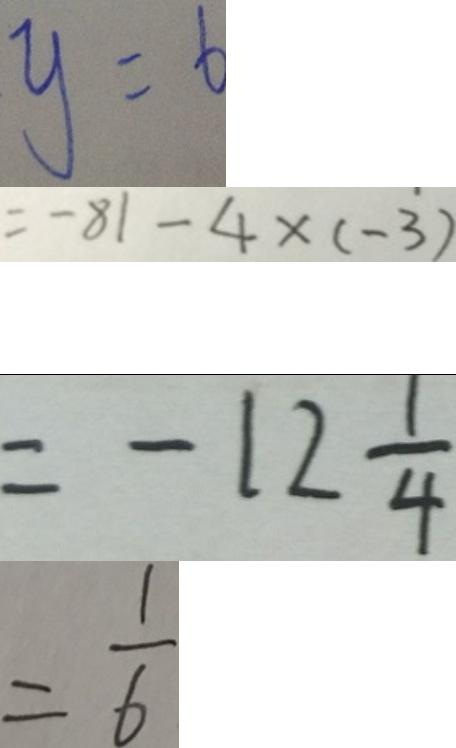<formula> <loc_0><loc_0><loc_500><loc_500>y = 6 
 = - 8 1 - 4 \times ( - 3 ) 
 = - 1 2 \frac { 1 } { 4 } 
 = \frac { 1 } { 6 }</formula> 